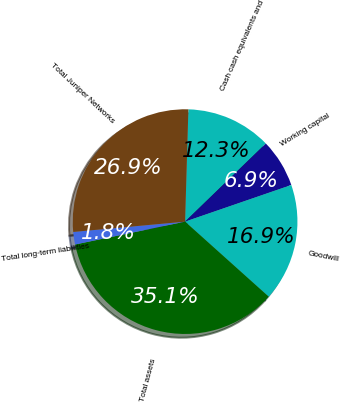Convert chart to OTSL. <chart><loc_0><loc_0><loc_500><loc_500><pie_chart><fcel>Cash cash equivalents and<fcel>Working capital<fcel>Goodwill<fcel>Total assets<fcel>Total long-term liabilities<fcel>Total Juniper Networks<nl><fcel>12.3%<fcel>6.95%<fcel>16.92%<fcel>35.1%<fcel>1.8%<fcel>26.93%<nl></chart> 